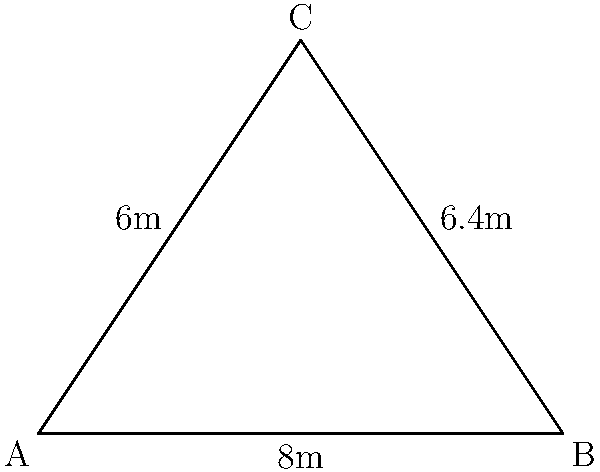During your BJJ warm-up, your instructor asks you to calculate the perimeter of a triangular area within the training space. The sides of the triangle measure 6m, 8m, and 6.4m. What is the perimeter of this warm-up area? Let's break this down step-by-step:

1. Recall that the perimeter of a shape is the sum of all its sides.

2. For a triangle, we simply need to add the lengths of all three sides.

3. We are given the following measurements:
   - Side 1: 6m
   - Side 2: 8m
   - Side 3: 6.4m

4. To calculate the perimeter, we add these lengths:

   $$\text{Perimeter} = 6\text{m} + 8\text{m} + 6.4\text{m}$$

5. Performing the addition:

   $$\text{Perimeter} = 20.4\text{m}$$

Therefore, the perimeter of the triangular warm-up area is 20.4 meters.
Answer: 20.4m 